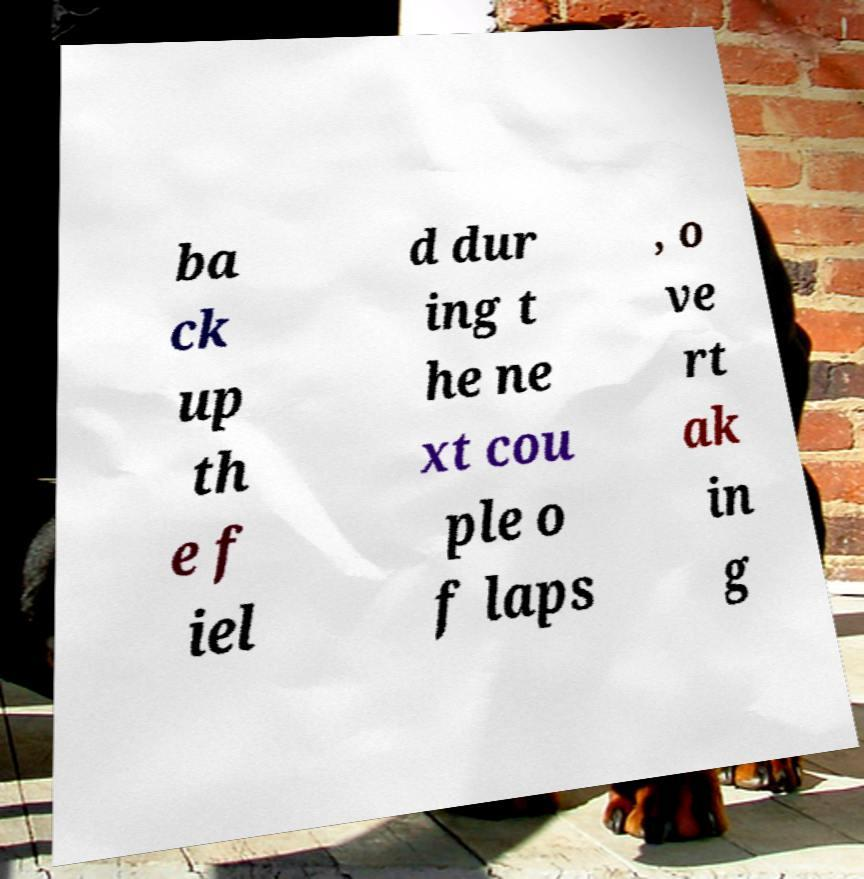There's text embedded in this image that I need extracted. Can you transcribe it verbatim? ba ck up th e f iel d dur ing t he ne xt cou ple o f laps , o ve rt ak in g 